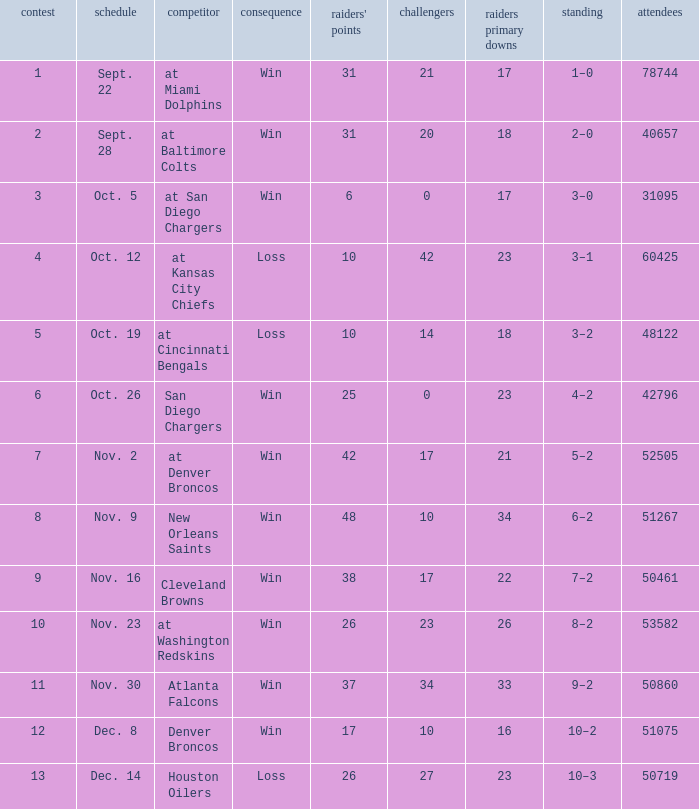How many different counts of the Raiders first downs are there for the game number 9? 1.0. 